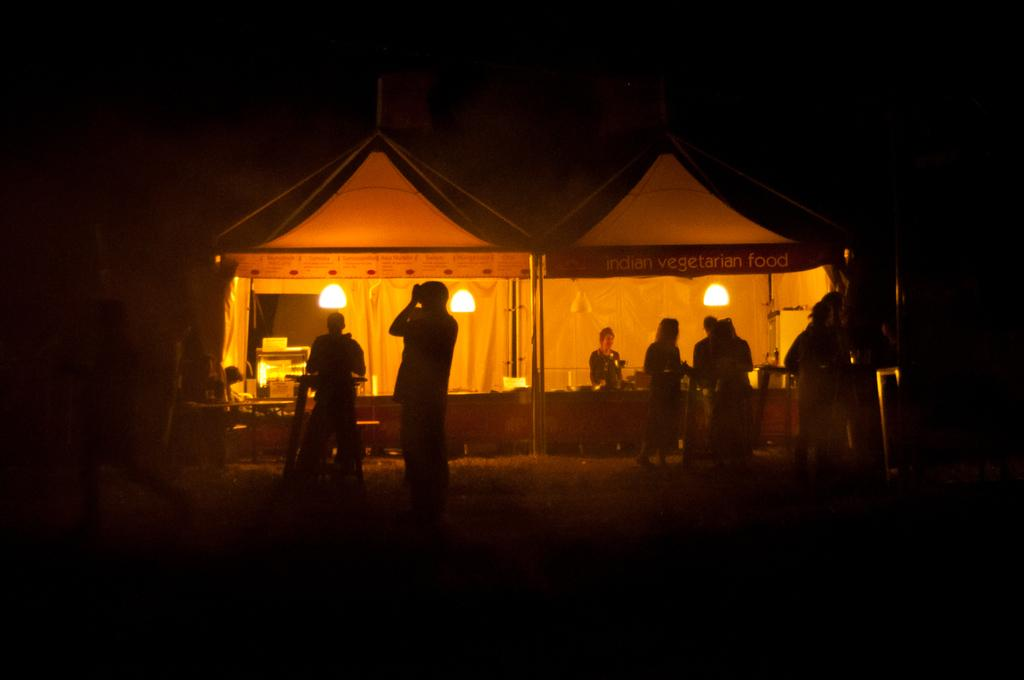What is happening in the image? There is a group of people standing in the image. Can you describe the setting of the image? There are people visible in the background of the image, and lights are present in the background as well. How would you describe the lighting conditions in the image? The background of the image is dark. What type of powder is being used by the people in the image? There is no powder visible in the image; it features a group of people standing with a dark background and lights in the background. 